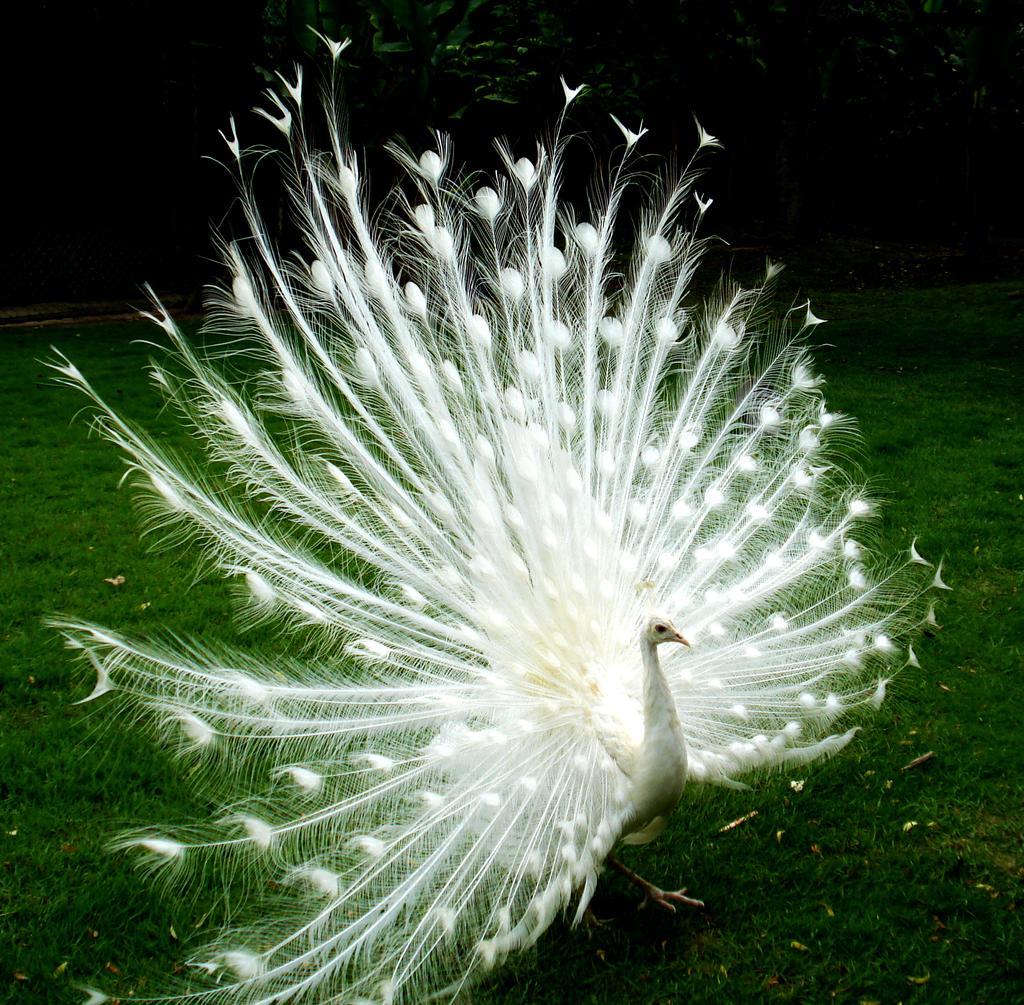In one or two sentences, can you explain what this image depicts? In this picture we can see a peacock is standing, at the bottom there is grass, in the background we can see trees, we can see peacock train in the middle. 